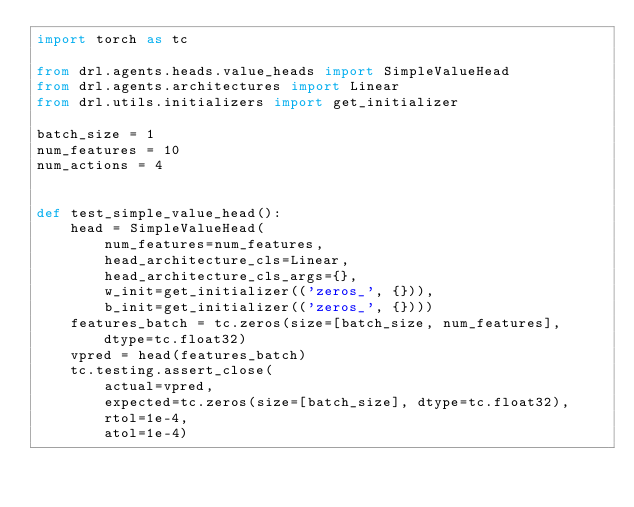<code> <loc_0><loc_0><loc_500><loc_500><_Python_>import torch as tc

from drl.agents.heads.value_heads import SimpleValueHead
from drl.agents.architectures import Linear
from drl.utils.initializers import get_initializer

batch_size = 1
num_features = 10
num_actions = 4


def test_simple_value_head():
    head = SimpleValueHead(
        num_features=num_features,
        head_architecture_cls=Linear,
        head_architecture_cls_args={},
        w_init=get_initializer(('zeros_', {})),
        b_init=get_initializer(('zeros_', {})))
    features_batch = tc.zeros(size=[batch_size, num_features], dtype=tc.float32)
    vpred = head(features_batch)
    tc.testing.assert_close(
        actual=vpred,
        expected=tc.zeros(size=[batch_size], dtype=tc.float32),
        rtol=1e-4,
        atol=1e-4)
</code> 